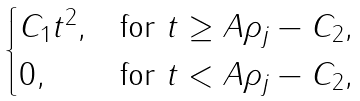<formula> <loc_0><loc_0><loc_500><loc_500>\begin{cases} C _ { 1 } t ^ { 2 } , & \text {for\ } t \geq A \rho _ { j } - C _ { 2 } , \\ 0 , & \text {for\ } t < A \rho _ { j } - C _ { 2 } , \end{cases}</formula> 